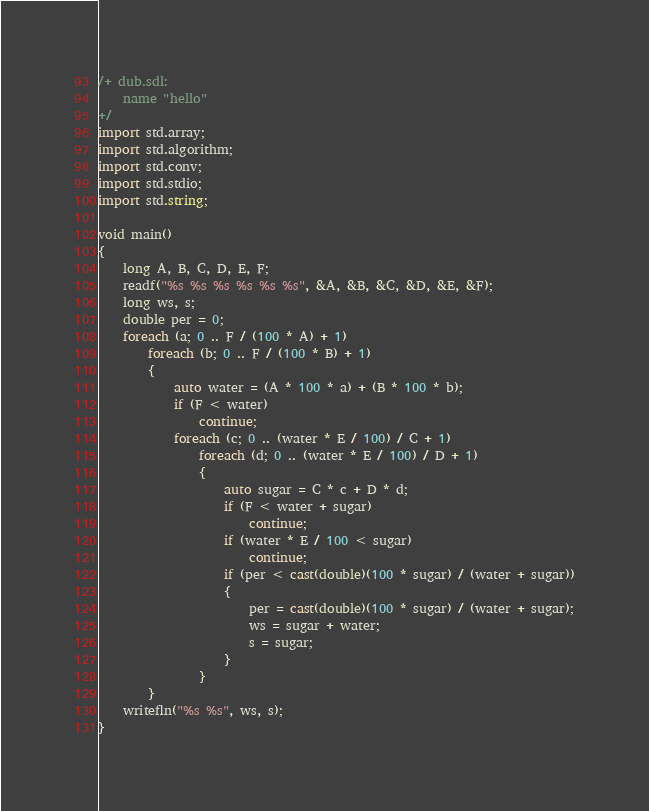Convert code to text. <code><loc_0><loc_0><loc_500><loc_500><_D_>/+ dub.sdl:
	name "hello"
+/
import std.array;
import std.algorithm;
import std.conv;
import std.stdio;
import std.string;

void main()
{
    long A, B, C, D, E, F;
    readf("%s %s %s %s %s %s", &A, &B, &C, &D, &E, &F);
    long ws, s;
    double per = 0;
    foreach (a; 0 .. F / (100 * A) + 1)
        foreach (b; 0 .. F / (100 * B) + 1)
        {
            auto water = (A * 100 * a) + (B * 100 * b);
            if (F < water)
                continue;
            foreach (c; 0 .. (water * E / 100) / C + 1)
                foreach (d; 0 .. (water * E / 100) / D + 1)
                {
                    auto sugar = C * c + D * d;
                    if (F < water + sugar)
                        continue;
                    if (water * E / 100 < sugar)
                        continue;
                    if (per < cast(double)(100 * sugar) / (water + sugar))
                    {
                        per = cast(double)(100 * sugar) / (water + sugar);
                        ws = sugar + water;
                        s = sugar;
                    }
                }
        }
    writefln("%s %s", ws, s);
}
</code> 